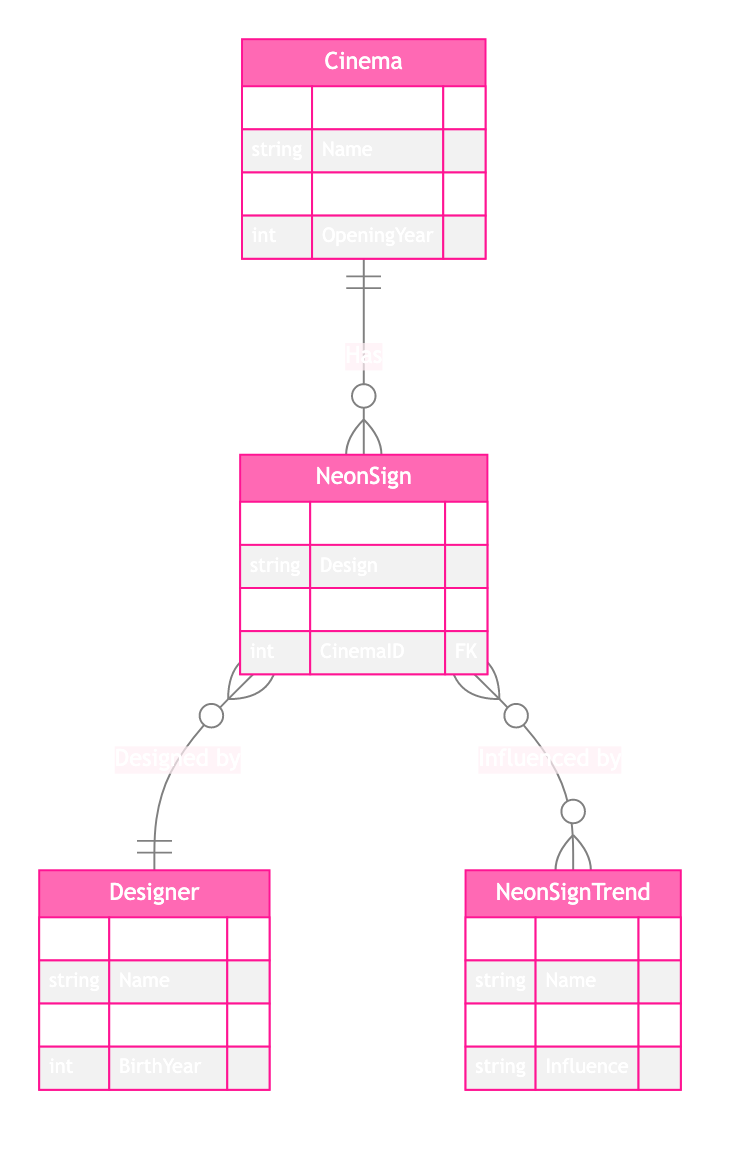What is the primary key for the Cinema entity? The primary key for the Cinema entity is CinemaID. It identifies each cinema uniquely within this entity.
Answer: CinemaID How many attributes are there in the NeonSign entity? The NeonSign entity has four attributes: SignID, Design, InstalledYear, and CinemaID. Count them to find the total.
Answer: Four What type of relationship exists between NeonSign and Designer? The relationship between NeonSign and Designer is a "Designed by" relationship, indicating that many NeonSigns can be designed by one Designer.
Answer: Designed by What is the primary key of the NeonSignTrend entity? The primary key of the NeonSignTrend entity is TrendID. This key uniquely identifies each trend related to neon signage.
Answer: TrendID Which entity has a one-to-many relationship with NeonSign? The Cinema entity has a one-to-many relationship with NeonSign, meaning one Cinema can have many NeonSigns associated with it.
Answer: Cinema What influences the NeonSign according to the diagram? NeonSigns are influenced by trends. The diagram shows a many-to-many relationship between NeonSign and NeonSignTrend.
Answer: Trends Which attribute describes the year a neon sign was installed? The attribute that describes the year a neon sign was installed is InstalledYear. It indicates when a specific sign was set up.
Answer: InstalledYear What is the relationship type between NeonSign and NeonSignTrend? The relationship type between NeonSign and NeonSignTrend is many-to-many, meaning multiple NeonSigns can be influenced by multiple trends.
Answer: Many-to-many How many primary keys are there in the Designer entity? The Designer entity has one primary key, which is DesignerID, uniquely identifying each designer.
Answer: One 